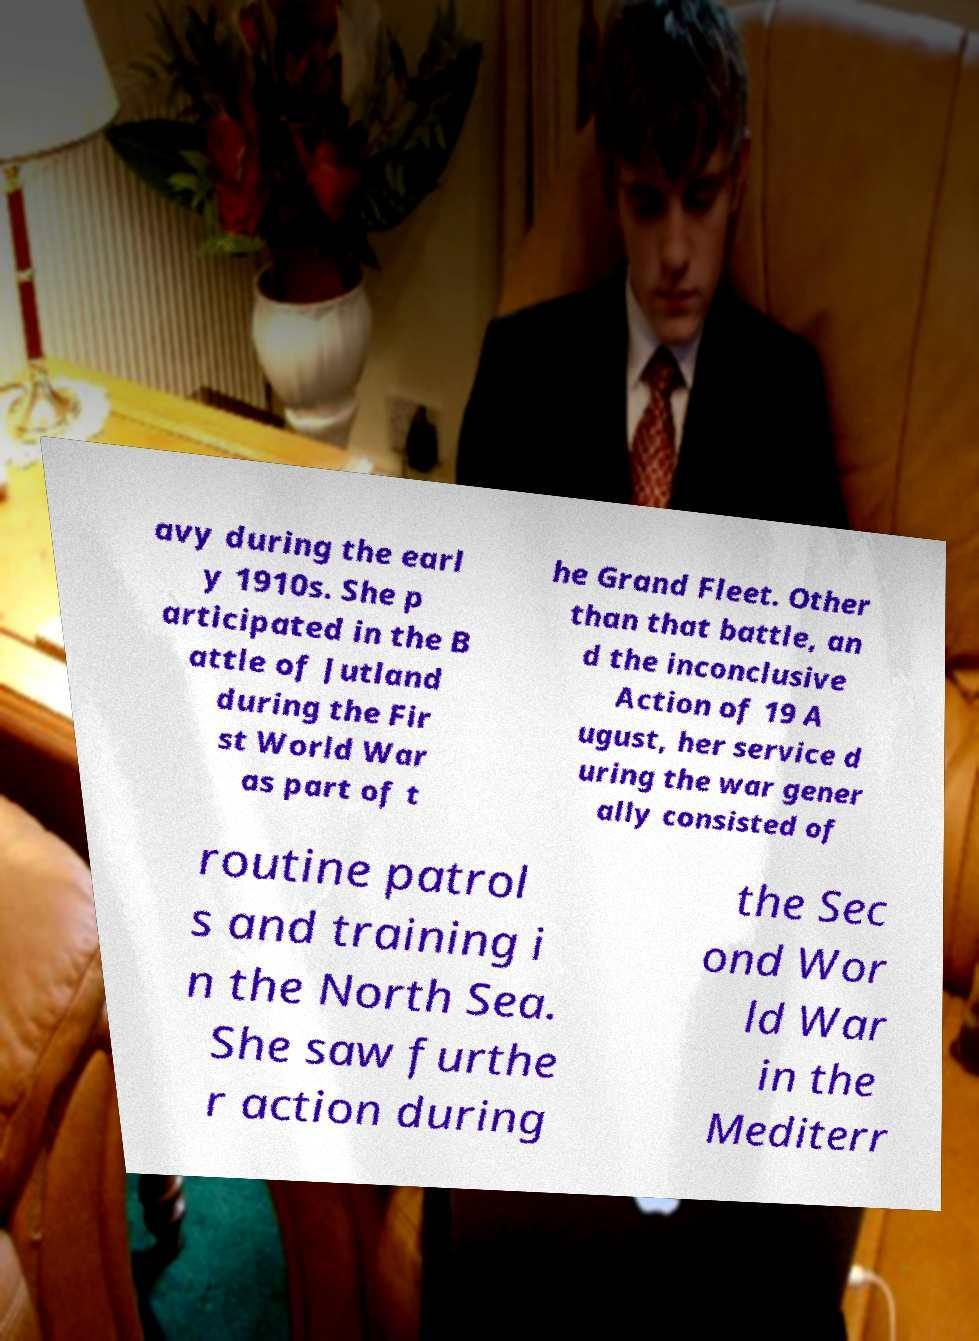What messages or text are displayed in this image? I need them in a readable, typed format. avy during the earl y 1910s. She p articipated in the B attle of Jutland during the Fir st World War as part of t he Grand Fleet. Other than that battle, an d the inconclusive Action of 19 A ugust, her service d uring the war gener ally consisted of routine patrol s and training i n the North Sea. She saw furthe r action during the Sec ond Wor ld War in the Mediterr 